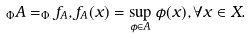Convert formula to latex. <formula><loc_0><loc_0><loc_500><loc_500>_ { \Phi } A = _ { \Phi } f _ { A } , f _ { A } ( x ) = \sup _ { \phi \in A } \phi ( x ) , \forall x \in X .</formula> 